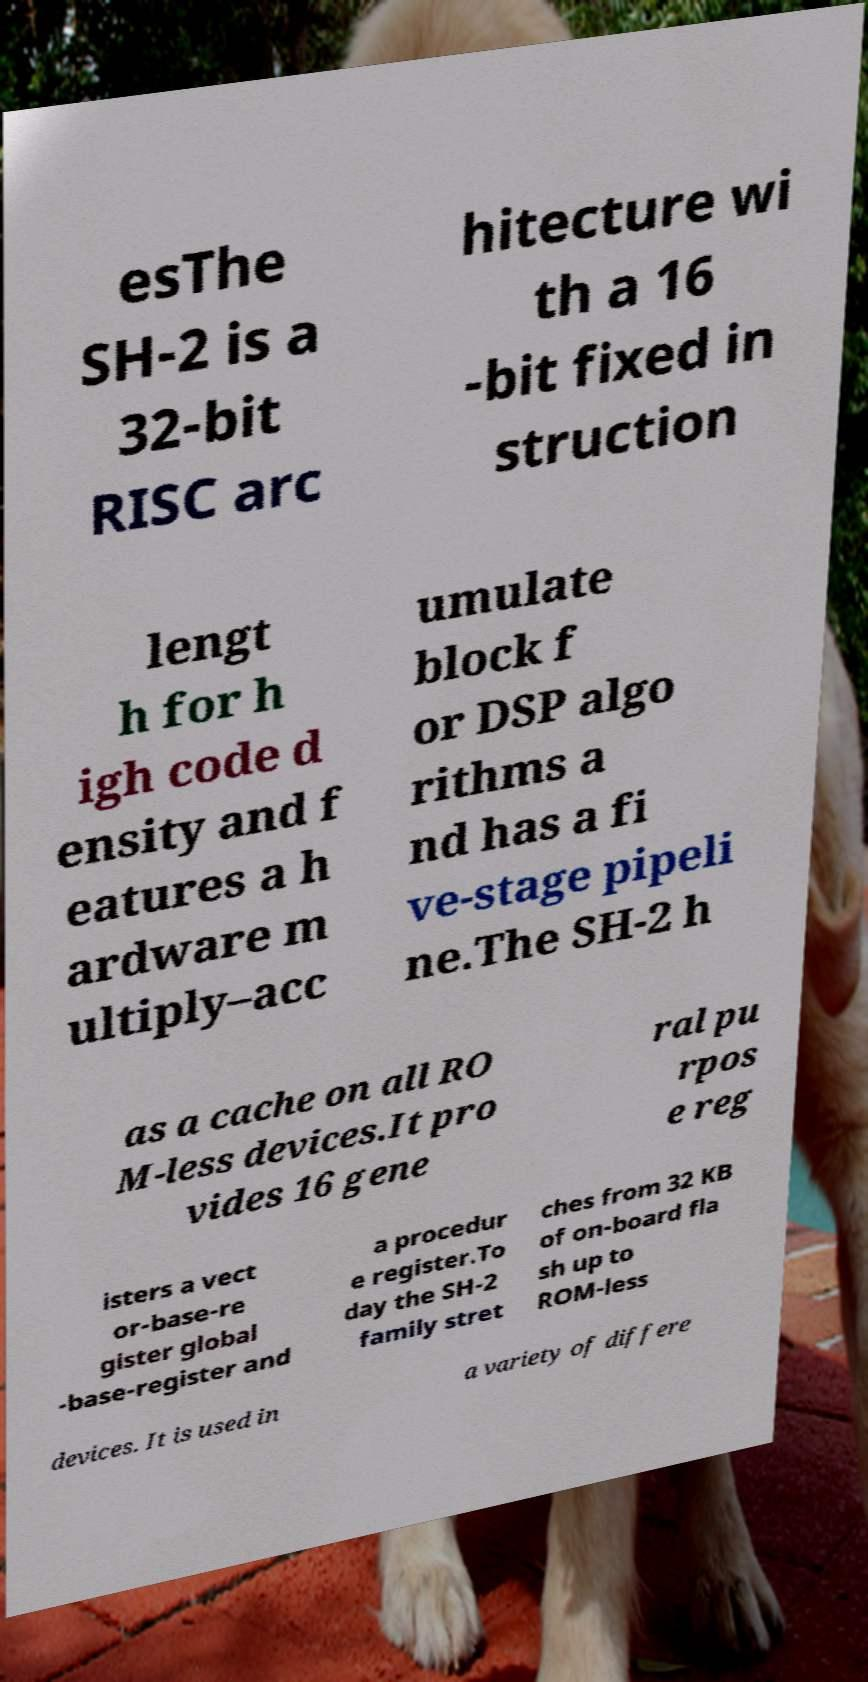I need the written content from this picture converted into text. Can you do that? esThe SH-2 is a 32-bit RISC arc hitecture wi th a 16 -bit fixed in struction lengt h for h igh code d ensity and f eatures a h ardware m ultiply–acc umulate block f or DSP algo rithms a nd has a fi ve-stage pipeli ne.The SH-2 h as a cache on all RO M-less devices.It pro vides 16 gene ral pu rpos e reg isters a vect or-base-re gister global -base-register and a procedur e register.To day the SH-2 family stret ches from 32 KB of on-board fla sh up to ROM-less devices. It is used in a variety of differe 